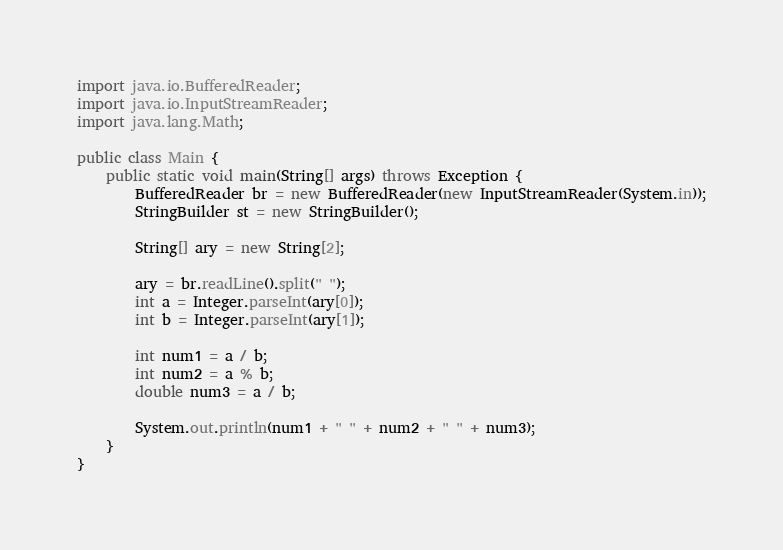<code> <loc_0><loc_0><loc_500><loc_500><_Java_>import java.io.BufferedReader;
import java.io.InputStreamReader;
import java.lang.Math;

public class Main {
    public static void main(String[] args) throws Exception {
        BufferedReader br = new BufferedReader(new InputStreamReader(System.in));
        StringBuilder st = new StringBuilder();
        
        String[] ary = new String[2];
        
        ary = br.readLine().split(" ");
        int a = Integer.parseInt(ary[0]);
        int b = Integer.parseInt(ary[1]);
        
        int num1 = a / b;
        int num2 = a % b;
        double num3 = a / b;
        
        System.out.println(num1 + " " + num2 + " " + num3);
    }
}</code> 